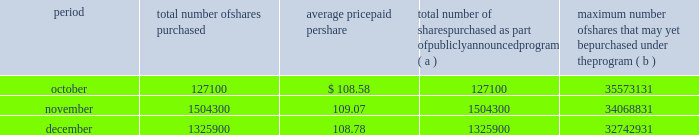Issuer purchases of equity securities the table provides information about our repurchases of common stock during the three-month period ended december 31 , 2007 .
Period total number of shares purchased average price paid per total number of shares purchased as part of publicly announced program ( a ) maximum number of shares that may yet be purchased under the program ( b ) .
( a ) we repurchased a total of 2957300 shares of our common stock during the quarter ended december 31 , 2007 under a share repurchase program that we announced in october 2002 .
( b ) our board of directors has approved a share repurchase program for the repurchase of up to 128 million shares of our common stock from time-to-time , including 20 million shares approved for repurchase by our board of directors in september 2007 .
Under the program , management has discretion to determine the number and price of the shares to be repurchased , and the timing of any repurchases , in compliance with applicable law and regulation .
As of december 31 , 2007 , we had repurchased a total of 95.3 million shares under the program .
In 2007 , we did not make any unregistered sales of equity securities. .
What percentage remains of the total approved shares for repurchased under the approved share repurchase program? 
Computations: ((128 - 95.3) / 128)
Answer: 0.25547. 